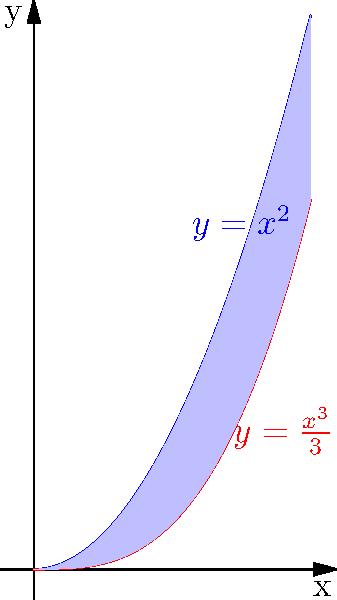As part of your advanced mathematics project, you're tasked with finding the area between two polynomial curves. The curves are given by $y=x^2$ and $y=\frac{x^3}{3}$ over the interval $[0,2]$. Calculate the area between these curves to demonstrate your understanding of integral calculus and its applications in finding areas between curves. To find the area between two curves, we need to follow these steps:

1) Identify the upper and lower curves:
   For $0 \leq x \leq 1$, $x^2 \geq \frac{x^3}{3}$
   For $1 \leq x \leq 2$, $\frac{x^3}{3} \geq x^2$

2) Set up the integral:
   Area = $\int_{0}^{1} (x^2 - \frac{x^3}{3}) dx + \int_{1}^{2} (\frac{x^3}{3} - x^2) dx$

3) Solve the first integral:
   $\int_{0}^{1} (x^2 - \frac{x^3}{3}) dx = [\frac{x^3}{3} - \frac{x^4}{12}]_{0}^{1} = \frac{1}{3} - \frac{1}{12} = \frac{1}{4}$

4) Solve the second integral:
   $\int_{1}^{2} (\frac{x^3}{3} - x^2) dx = [\frac{x^4}{12} - \frac{x^3}{3}]_{1}^{2} = (\frac{16}{12} - \frac{8}{3}) - (\frac{1}{12} - \frac{1}{3}) = \frac{1}{3} - \frac{1}{4} = \frac{1}{12}$

5) Sum the results:
   Total Area = $\frac{1}{4} + \frac{1}{12} = \frac{1}{3}$

Therefore, the area between the curves $y=x^2$ and $y=\frac{x^3}{3}$ over the interval $[0,2]$ is $\frac{1}{3}$ square units.
Answer: $\frac{1}{3}$ square units 